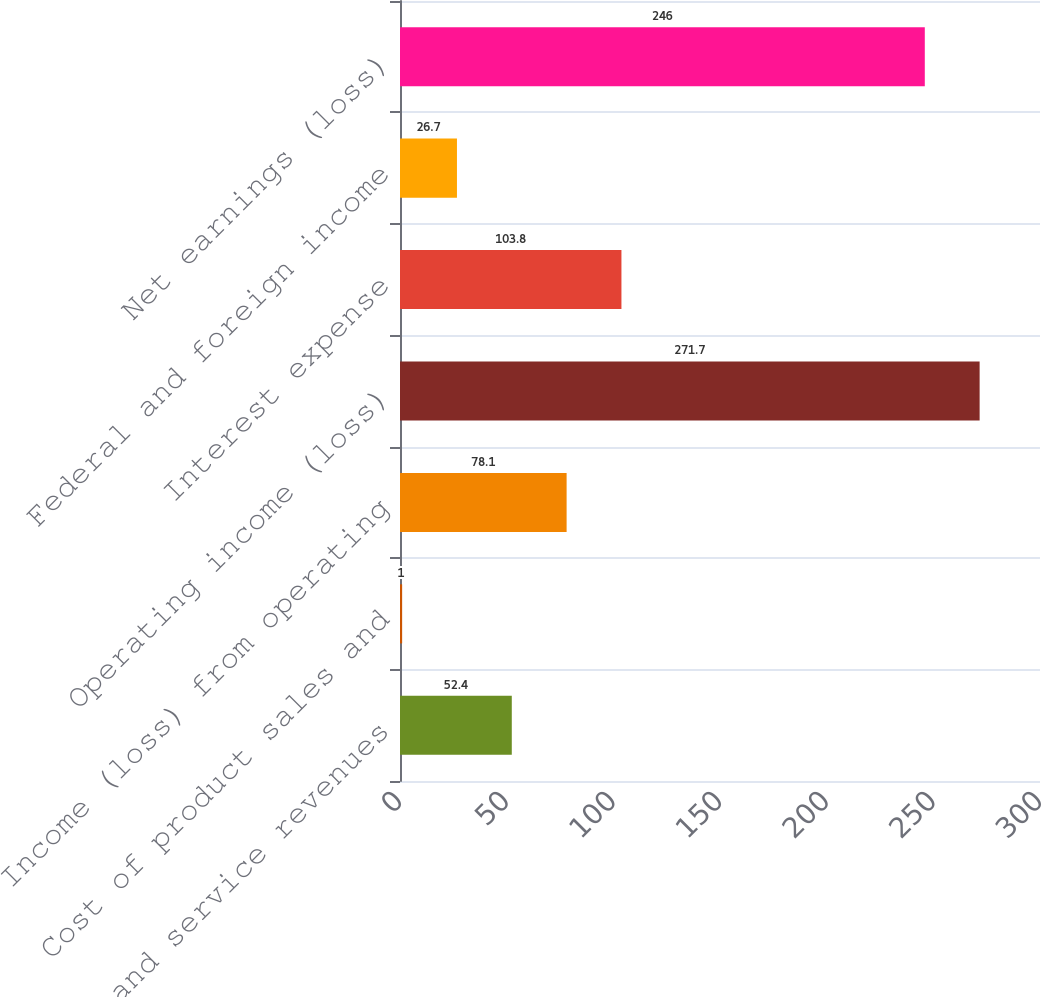Convert chart to OTSL. <chart><loc_0><loc_0><loc_500><loc_500><bar_chart><fcel>Sales and service revenues<fcel>Cost of product sales and<fcel>Income (loss) from operating<fcel>Operating income (loss)<fcel>Interest expense<fcel>Federal and foreign income<fcel>Net earnings (loss)<nl><fcel>52.4<fcel>1<fcel>78.1<fcel>271.7<fcel>103.8<fcel>26.7<fcel>246<nl></chart> 